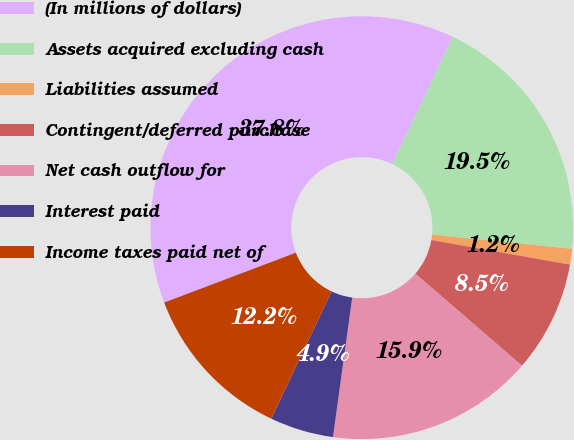Convert chart. <chart><loc_0><loc_0><loc_500><loc_500><pie_chart><fcel>(In millions of dollars)<fcel>Assets acquired excluding cash<fcel>Liabilities assumed<fcel>Contingent/deferred purchase<fcel>Net cash outflow for<fcel>Interest paid<fcel>Income taxes paid net of<nl><fcel>37.84%<fcel>19.52%<fcel>1.2%<fcel>8.53%<fcel>15.86%<fcel>4.87%<fcel>12.19%<nl></chart> 